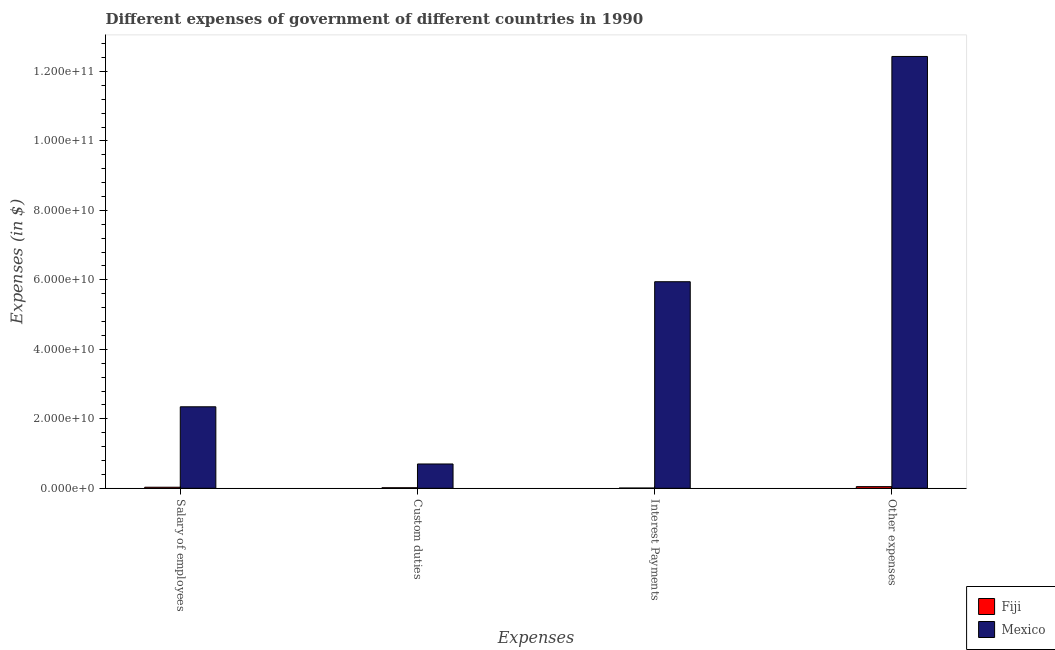How many different coloured bars are there?
Offer a terse response. 2. How many groups of bars are there?
Your response must be concise. 4. Are the number of bars per tick equal to the number of legend labels?
Your response must be concise. Yes. How many bars are there on the 3rd tick from the left?
Your answer should be compact. 2. What is the label of the 2nd group of bars from the left?
Provide a short and direct response. Custom duties. What is the amount spent on salary of employees in Fiji?
Ensure brevity in your answer.  3.04e+08. Across all countries, what is the maximum amount spent on custom duties?
Your answer should be very brief. 7.00e+09. Across all countries, what is the minimum amount spent on other expenses?
Give a very brief answer. 4.74e+08. In which country was the amount spent on custom duties minimum?
Provide a short and direct response. Fiji. What is the total amount spent on custom duties in the graph?
Keep it short and to the point. 7.15e+09. What is the difference between the amount spent on interest payments in Fiji and that in Mexico?
Ensure brevity in your answer.  -5.94e+1. What is the difference between the amount spent on other expenses in Fiji and the amount spent on interest payments in Mexico?
Give a very brief answer. -5.90e+1. What is the average amount spent on custom duties per country?
Ensure brevity in your answer.  3.58e+09. What is the difference between the amount spent on salary of employees and amount spent on interest payments in Mexico?
Provide a succinct answer. -3.60e+1. In how many countries, is the amount spent on custom duties greater than 12000000000 $?
Give a very brief answer. 0. What is the ratio of the amount spent on interest payments in Mexico to that in Fiji?
Give a very brief answer. 867.99. Is the amount spent on other expenses in Mexico less than that in Fiji?
Make the answer very short. No. What is the difference between the highest and the second highest amount spent on salary of employees?
Provide a succinct answer. 2.32e+1. What is the difference between the highest and the lowest amount spent on custom duties?
Keep it short and to the point. 6.84e+09. Is the sum of the amount spent on custom duties in Mexico and Fiji greater than the maximum amount spent on interest payments across all countries?
Provide a succinct answer. No. Is it the case that in every country, the sum of the amount spent on custom duties and amount spent on salary of employees is greater than the sum of amount spent on other expenses and amount spent on interest payments?
Offer a very short reply. No. How many bars are there?
Your answer should be very brief. 8. How are the legend labels stacked?
Your answer should be very brief. Vertical. What is the title of the graph?
Offer a terse response. Different expenses of government of different countries in 1990. What is the label or title of the X-axis?
Provide a short and direct response. Expenses. What is the label or title of the Y-axis?
Your answer should be very brief. Expenses (in $). What is the Expenses (in $) in Fiji in Salary of employees?
Ensure brevity in your answer.  3.04e+08. What is the Expenses (in $) of Mexico in Salary of employees?
Your answer should be very brief. 2.35e+1. What is the Expenses (in $) of Fiji in Custom duties?
Your response must be concise. 1.56e+08. What is the Expenses (in $) of Mexico in Custom duties?
Your answer should be very brief. 7.00e+09. What is the Expenses (in $) of Fiji in Interest Payments?
Your response must be concise. 6.85e+07. What is the Expenses (in $) in Mexico in Interest Payments?
Your response must be concise. 5.95e+1. What is the Expenses (in $) in Fiji in Other expenses?
Ensure brevity in your answer.  4.74e+08. What is the Expenses (in $) in Mexico in Other expenses?
Make the answer very short. 1.24e+11. Across all Expenses, what is the maximum Expenses (in $) of Fiji?
Make the answer very short. 4.74e+08. Across all Expenses, what is the maximum Expenses (in $) of Mexico?
Ensure brevity in your answer.  1.24e+11. Across all Expenses, what is the minimum Expenses (in $) in Fiji?
Give a very brief answer. 6.85e+07. Across all Expenses, what is the minimum Expenses (in $) of Mexico?
Make the answer very short. 7.00e+09. What is the total Expenses (in $) of Fiji in the graph?
Your answer should be compact. 1.00e+09. What is the total Expenses (in $) of Mexico in the graph?
Make the answer very short. 2.14e+11. What is the difference between the Expenses (in $) in Fiji in Salary of employees and that in Custom duties?
Provide a succinct answer. 1.48e+08. What is the difference between the Expenses (in $) in Mexico in Salary of employees and that in Custom duties?
Provide a succinct answer. 1.65e+1. What is the difference between the Expenses (in $) of Fiji in Salary of employees and that in Interest Payments?
Your answer should be compact. 2.35e+08. What is the difference between the Expenses (in $) in Mexico in Salary of employees and that in Interest Payments?
Provide a short and direct response. -3.60e+1. What is the difference between the Expenses (in $) of Fiji in Salary of employees and that in Other expenses?
Your answer should be compact. -1.71e+08. What is the difference between the Expenses (in $) of Mexico in Salary of employees and that in Other expenses?
Offer a very short reply. -1.01e+11. What is the difference between the Expenses (in $) in Fiji in Custom duties and that in Interest Payments?
Make the answer very short. 8.71e+07. What is the difference between the Expenses (in $) in Mexico in Custom duties and that in Interest Payments?
Keep it short and to the point. -5.25e+1. What is the difference between the Expenses (in $) of Fiji in Custom duties and that in Other expenses?
Offer a very short reply. -3.19e+08. What is the difference between the Expenses (in $) in Mexico in Custom duties and that in Other expenses?
Offer a terse response. -1.17e+11. What is the difference between the Expenses (in $) of Fiji in Interest Payments and that in Other expenses?
Make the answer very short. -4.06e+08. What is the difference between the Expenses (in $) of Mexico in Interest Payments and that in Other expenses?
Offer a terse response. -6.49e+1. What is the difference between the Expenses (in $) of Fiji in Salary of employees and the Expenses (in $) of Mexico in Custom duties?
Offer a very short reply. -6.69e+09. What is the difference between the Expenses (in $) of Fiji in Salary of employees and the Expenses (in $) of Mexico in Interest Payments?
Keep it short and to the point. -5.92e+1. What is the difference between the Expenses (in $) in Fiji in Salary of employees and the Expenses (in $) in Mexico in Other expenses?
Offer a terse response. -1.24e+11. What is the difference between the Expenses (in $) in Fiji in Custom duties and the Expenses (in $) in Mexico in Interest Payments?
Keep it short and to the point. -5.93e+1. What is the difference between the Expenses (in $) in Fiji in Custom duties and the Expenses (in $) in Mexico in Other expenses?
Make the answer very short. -1.24e+11. What is the difference between the Expenses (in $) in Fiji in Interest Payments and the Expenses (in $) in Mexico in Other expenses?
Ensure brevity in your answer.  -1.24e+11. What is the average Expenses (in $) of Fiji per Expenses?
Your answer should be compact. 2.51e+08. What is the average Expenses (in $) in Mexico per Expenses?
Give a very brief answer. 5.36e+1. What is the difference between the Expenses (in $) of Fiji and Expenses (in $) of Mexico in Salary of employees?
Make the answer very short. -2.32e+1. What is the difference between the Expenses (in $) in Fiji and Expenses (in $) in Mexico in Custom duties?
Your answer should be very brief. -6.84e+09. What is the difference between the Expenses (in $) of Fiji and Expenses (in $) of Mexico in Interest Payments?
Offer a very short reply. -5.94e+1. What is the difference between the Expenses (in $) of Fiji and Expenses (in $) of Mexico in Other expenses?
Your answer should be very brief. -1.24e+11. What is the ratio of the Expenses (in $) in Fiji in Salary of employees to that in Custom duties?
Keep it short and to the point. 1.95. What is the ratio of the Expenses (in $) of Mexico in Salary of employees to that in Custom duties?
Your response must be concise. 3.35. What is the ratio of the Expenses (in $) of Fiji in Salary of employees to that in Interest Payments?
Offer a very short reply. 4.43. What is the ratio of the Expenses (in $) of Mexico in Salary of employees to that in Interest Payments?
Provide a short and direct response. 0.39. What is the ratio of the Expenses (in $) in Fiji in Salary of employees to that in Other expenses?
Provide a succinct answer. 0.64. What is the ratio of the Expenses (in $) in Mexico in Salary of employees to that in Other expenses?
Provide a short and direct response. 0.19. What is the ratio of the Expenses (in $) in Fiji in Custom duties to that in Interest Payments?
Ensure brevity in your answer.  2.27. What is the ratio of the Expenses (in $) in Mexico in Custom duties to that in Interest Payments?
Keep it short and to the point. 0.12. What is the ratio of the Expenses (in $) in Fiji in Custom duties to that in Other expenses?
Your answer should be very brief. 0.33. What is the ratio of the Expenses (in $) in Mexico in Custom duties to that in Other expenses?
Make the answer very short. 0.06. What is the ratio of the Expenses (in $) in Fiji in Interest Payments to that in Other expenses?
Keep it short and to the point. 0.14. What is the ratio of the Expenses (in $) in Mexico in Interest Payments to that in Other expenses?
Make the answer very short. 0.48. What is the difference between the highest and the second highest Expenses (in $) of Fiji?
Offer a terse response. 1.71e+08. What is the difference between the highest and the second highest Expenses (in $) of Mexico?
Offer a very short reply. 6.49e+1. What is the difference between the highest and the lowest Expenses (in $) in Fiji?
Give a very brief answer. 4.06e+08. What is the difference between the highest and the lowest Expenses (in $) of Mexico?
Keep it short and to the point. 1.17e+11. 